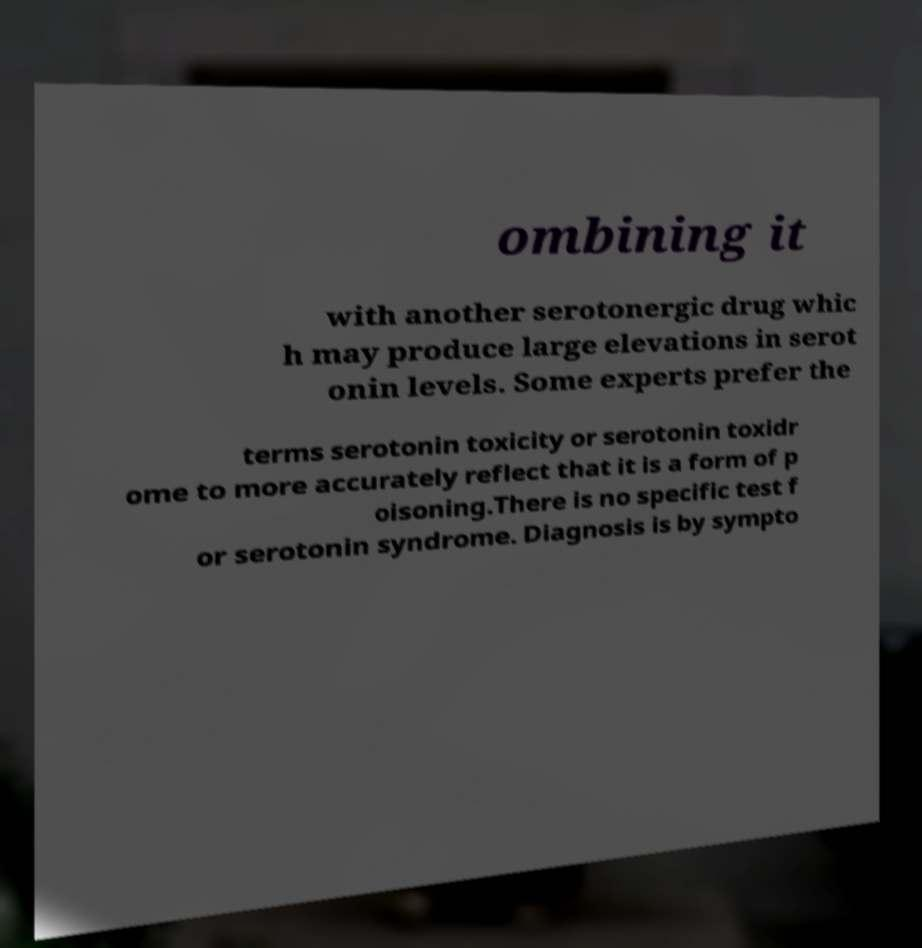Please identify and transcribe the text found in this image. ombining it with another serotonergic drug whic h may produce large elevations in serot onin levels. Some experts prefer the terms serotonin toxicity or serotonin toxidr ome to more accurately reflect that it is a form of p oisoning.There is no specific test f or serotonin syndrome. Diagnosis is by sympto 